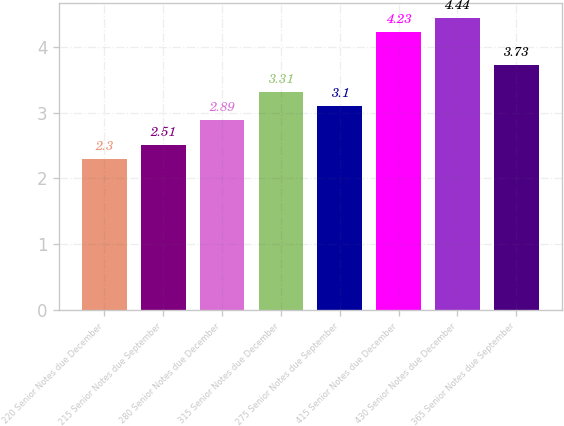Convert chart. <chart><loc_0><loc_0><loc_500><loc_500><bar_chart><fcel>220 Senior Notes due December<fcel>215 Senior Notes due September<fcel>280 Senior Notes due December<fcel>315 Senior Notes due December<fcel>275 Senior Notes due September<fcel>415 Senior Notes due December<fcel>430 Senior Notes due December<fcel>365 Senior Notes due September<nl><fcel>2.3<fcel>2.51<fcel>2.89<fcel>3.31<fcel>3.1<fcel>4.23<fcel>4.44<fcel>3.73<nl></chart> 